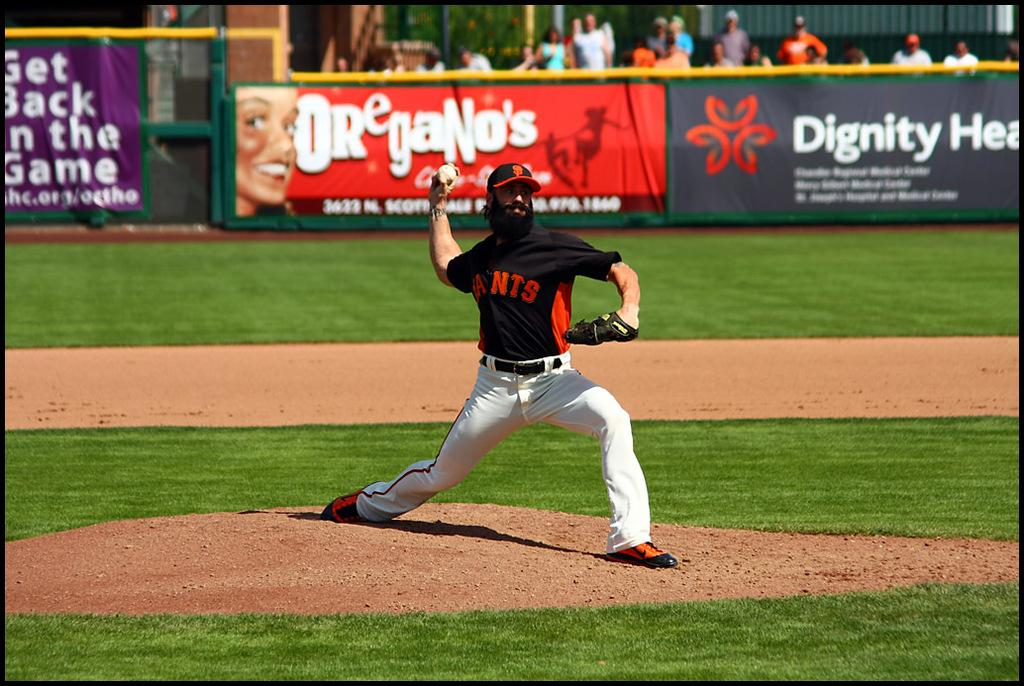<image>
Give a short and clear explanation of the subsequent image. Man wearing a black jersey that says Ants pitching the ball. 